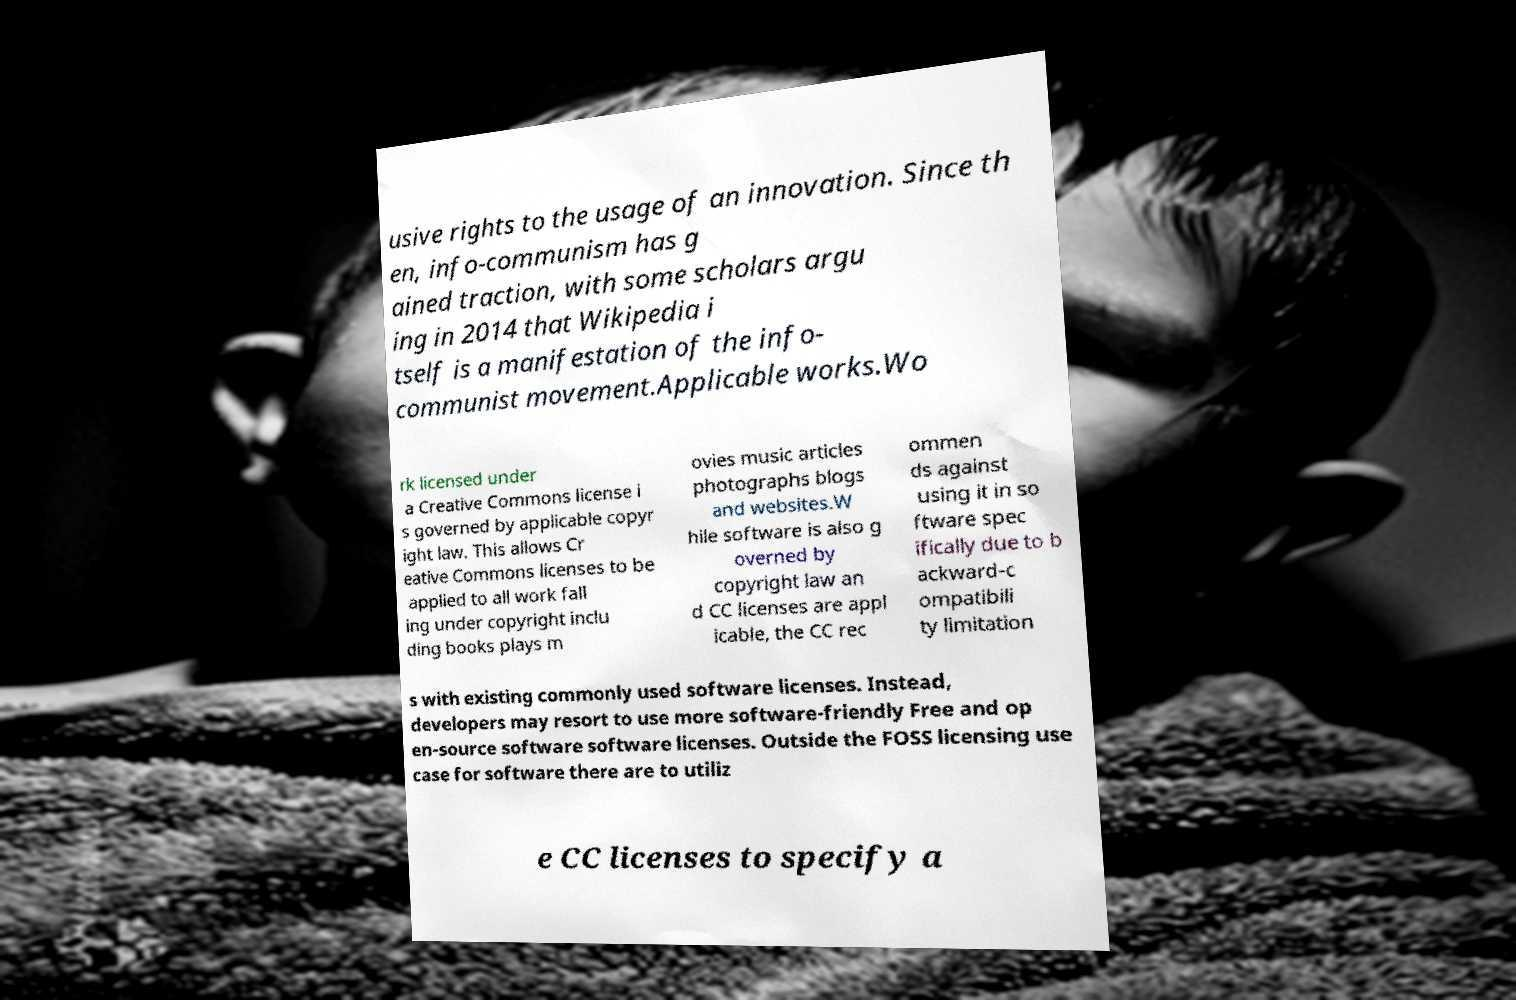Please identify and transcribe the text found in this image. usive rights to the usage of an innovation. Since th en, info-communism has g ained traction, with some scholars argu ing in 2014 that Wikipedia i tself is a manifestation of the info- communist movement.Applicable works.Wo rk licensed under a Creative Commons license i s governed by applicable copyr ight law. This allows Cr eative Commons licenses to be applied to all work fall ing under copyright inclu ding books plays m ovies music articles photographs blogs and websites.W hile software is also g overned by copyright law an d CC licenses are appl icable, the CC rec ommen ds against using it in so ftware spec ifically due to b ackward-c ompatibili ty limitation s with existing commonly used software licenses. Instead, developers may resort to use more software-friendly Free and op en-source software software licenses. Outside the FOSS licensing use case for software there are to utiliz e CC licenses to specify a 